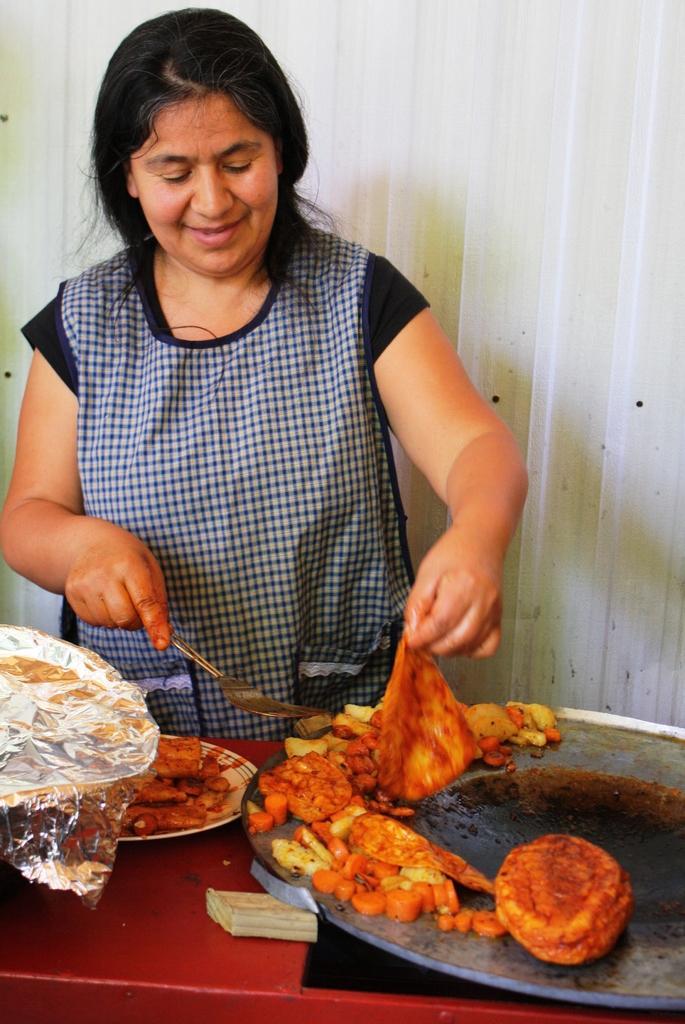In one or two sentences, can you explain what this image depicts? In this picture we can see a woman is holding an object and food item. In front of the woman it looks like a table and on the table there is a pan, aluminium foil and plate. On the plate and the pain there are some food items. Behind the woman there is an iron wall. 